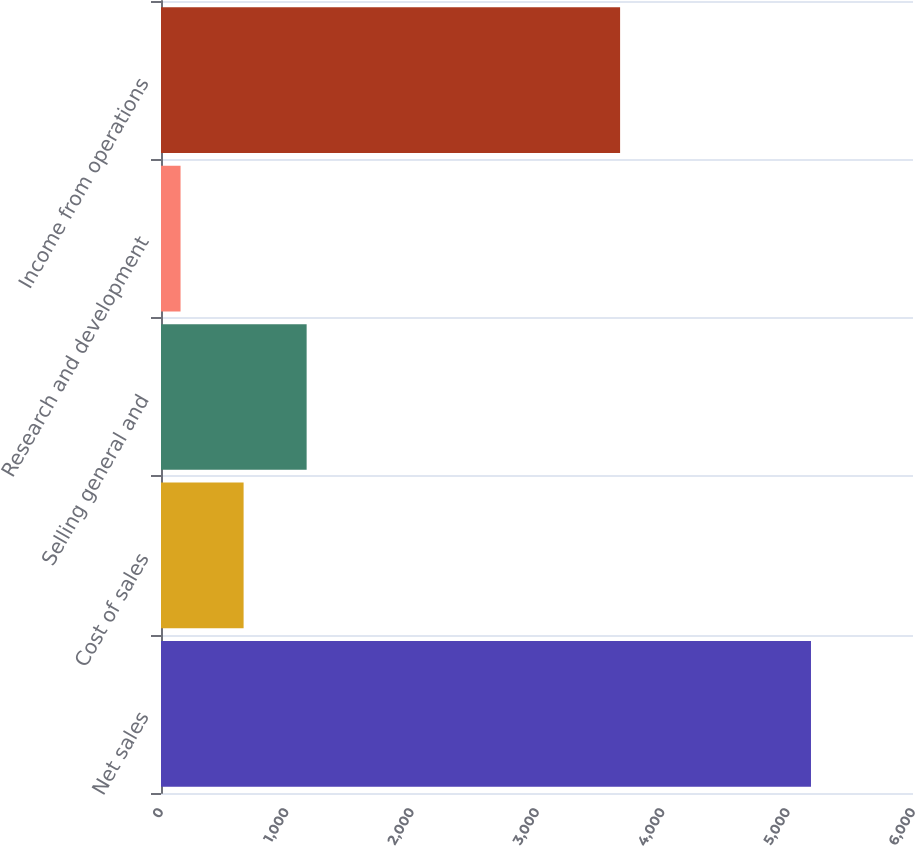Convert chart to OTSL. <chart><loc_0><loc_0><loc_500><loc_500><bar_chart><fcel>Net sales<fcel>Cost of sales<fcel>Selling general and<fcel>Research and development<fcel>Income from operations<nl><fcel>5186<fcel>659<fcel>1162<fcel>156<fcel>3663<nl></chart> 